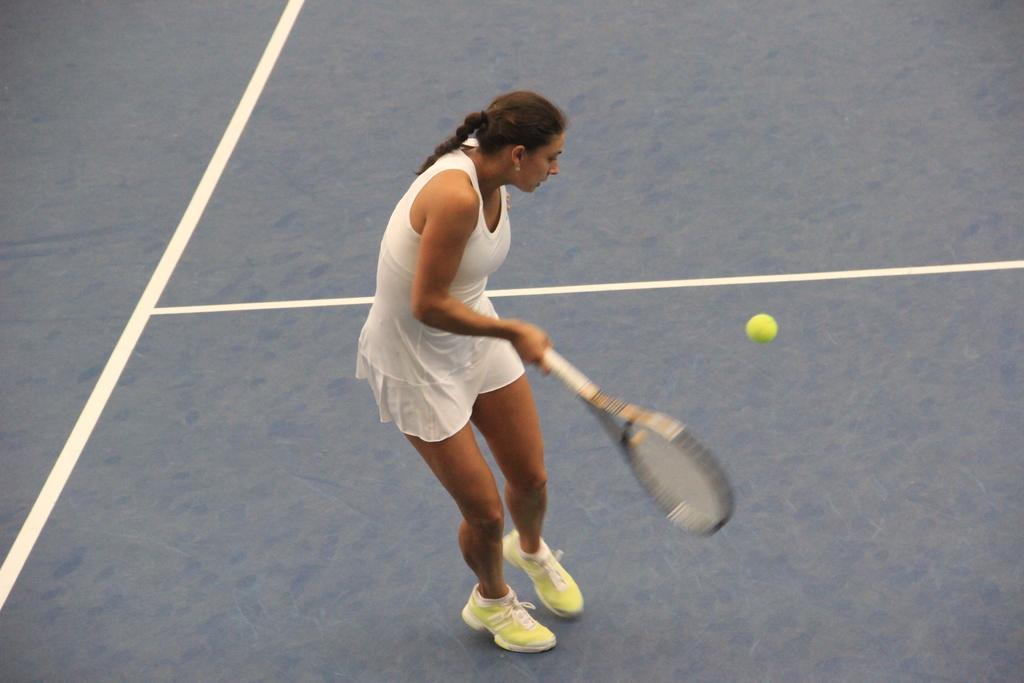Can you describe this image briefly? In the picture we can see a woman playing a tennis, holding a tennis racket and hitting a ball. 